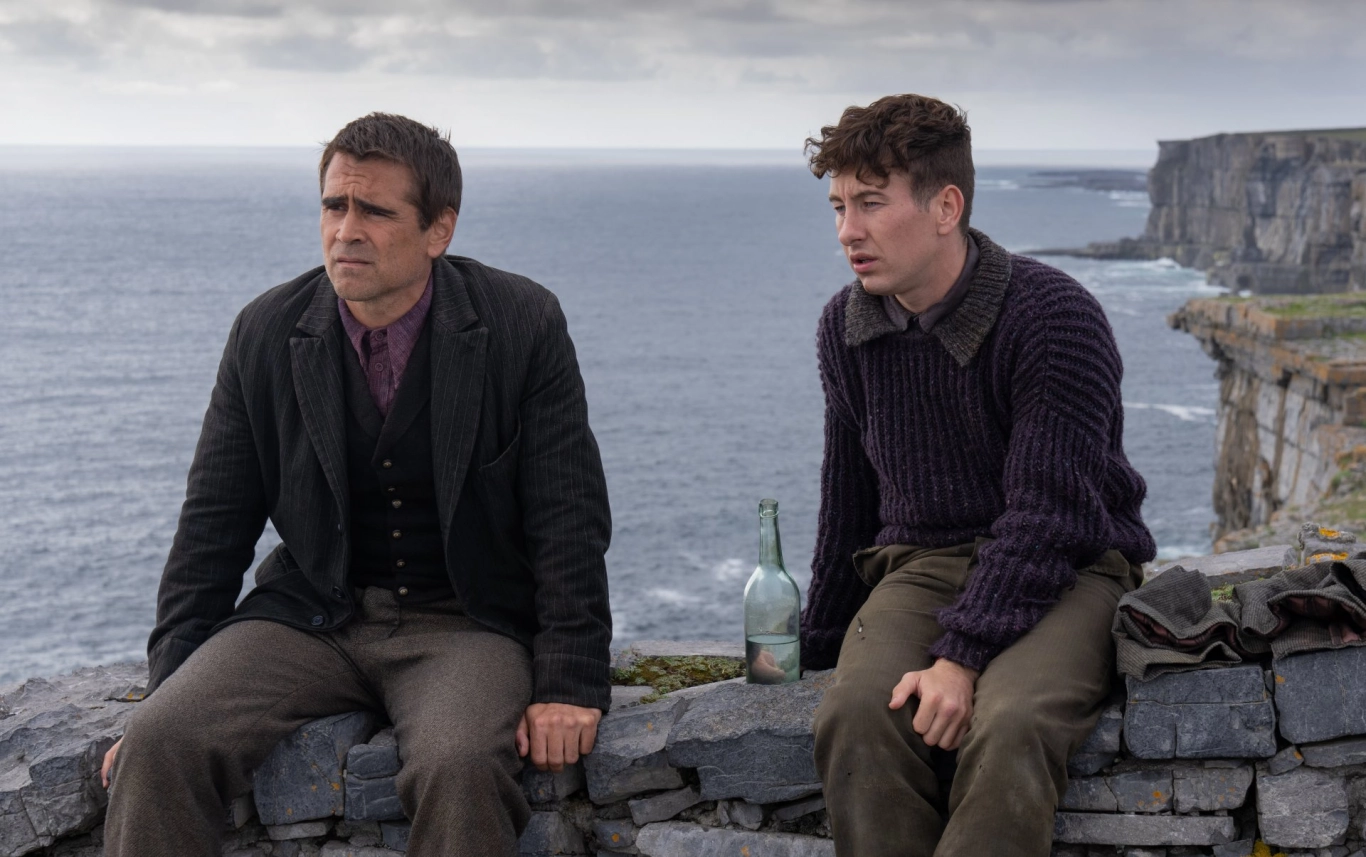What do you think these two individuals are thinking about? Both individuals appear lost in deep thought, possibly reflecting on their journey or contemplating their next steps. The serene yet rugged backdrop of the ocean and cliffs may evoke thoughts about the vast possibilities the horizon holds or perhaps they are grappling with unresolved issues from their travels. Can you create a short story based on this image? Once friends and fellow adventurers, Liam and Jack find themselves at a crossroads, both in their journey and in their relationship. Their path has led them to this stunning cliffside overlooking the vast ocean. Liam, dressed in a dark suit, ponders whether his ambitions have driven a wedge between them, while Jack, in his purple sweater, wonders if their simpler days of camaraderie are long gone. Between them, the bottle and backpack serve as quiet reminders of their shared past, a past that now feels distant as they face an uncertain future. 